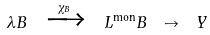<formula> <loc_0><loc_0><loc_500><loc_500>\lambda B \ \xrightarrow { \chi _ { B } } \ L ^ { \text {mon} } B \ \to \ Y</formula> 